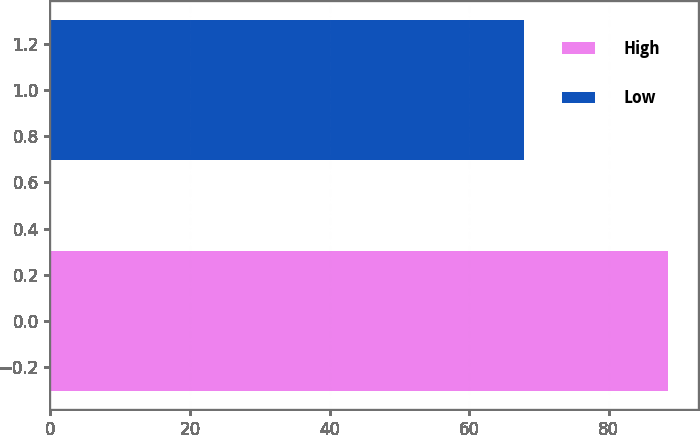Convert chart to OTSL. <chart><loc_0><loc_0><loc_500><loc_500><bar_chart><fcel>High<fcel>Low<nl><fcel>88.46<fcel>67.87<nl></chart> 